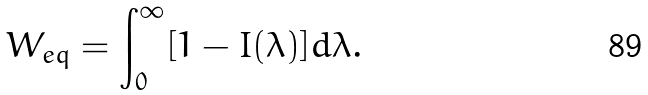Convert formula to latex. <formula><loc_0><loc_0><loc_500><loc_500>W _ { e q } = \int _ { 0 } ^ { \infty } [ 1 - I ( \lambda ) ] d \lambda .</formula> 